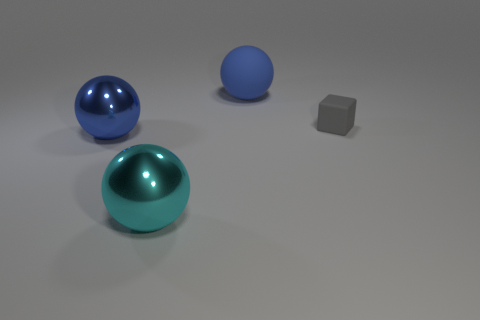Do the tiny thing and the rubber thing behind the cube have the same shape?
Offer a very short reply. No. How many gray rubber objects have the same size as the cyan shiny object?
Provide a succinct answer. 0. Do the blue object to the left of the large blue rubber thing and the large object in front of the big blue shiny ball have the same shape?
Offer a very short reply. Yes. There is a metal thing that is the same color as the large rubber object; what is its shape?
Provide a succinct answer. Sphere. What is the color of the big thing that is behind the rubber object that is to the right of the large blue matte object?
Give a very brief answer. Blue. There is another large rubber object that is the same shape as the large cyan thing; what color is it?
Offer a terse response. Blue. Is there anything else that has the same material as the gray thing?
Offer a very short reply. Yes. There is a cyan thing that is the same shape as the blue matte thing; what size is it?
Your answer should be very brief. Large. What material is the large blue ball that is behind the gray rubber block?
Keep it short and to the point. Rubber. Are there fewer cyan shiny spheres that are in front of the tiny block than tiny green metal cubes?
Keep it short and to the point. No. 